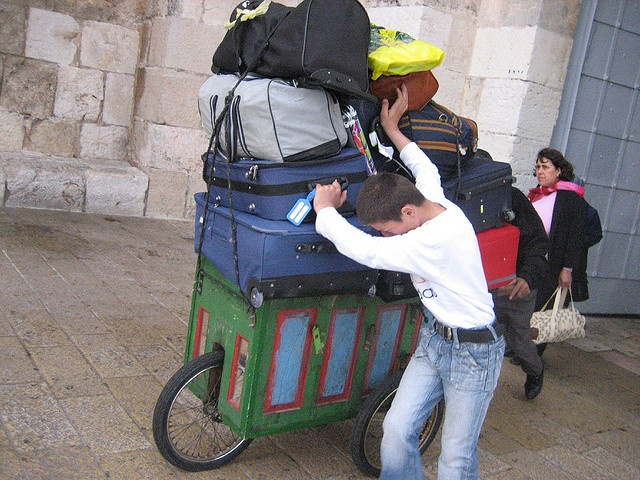Describe the objects in this image and their specific colors. I can see people in gray, white, and darkgray tones, suitcase in gray, black, and darkgray tones, suitcase in gray, black, and darkblue tones, suitcase in gray, black, blue, and darkblue tones, and people in gray, black, brown, and lavender tones in this image. 